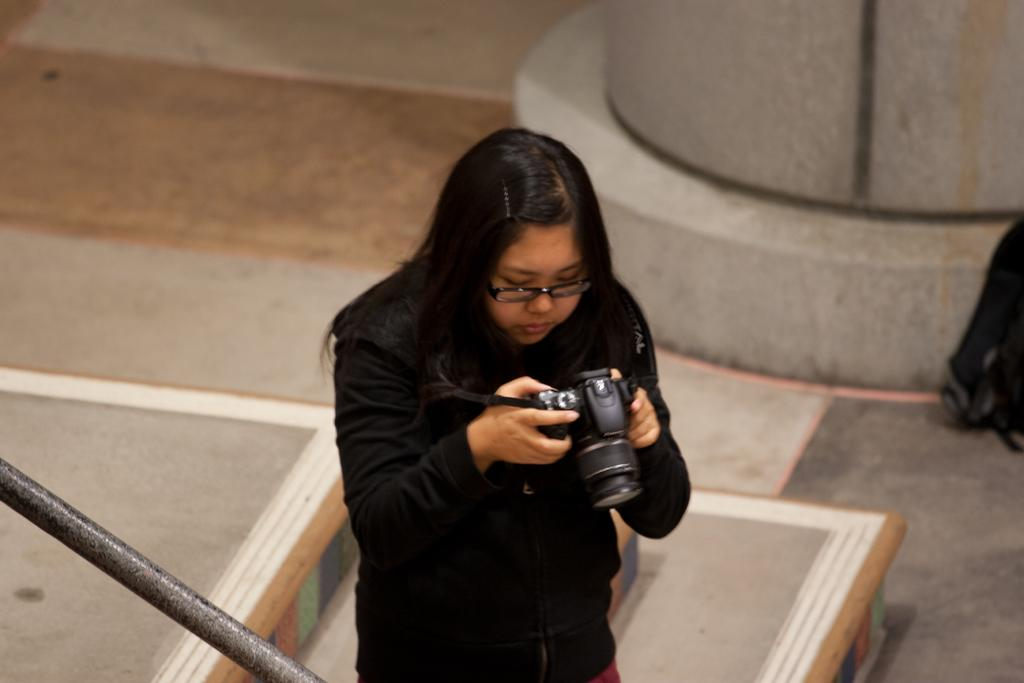What is the person in the image doing? The person is standing in the image and holding a camera. What can be seen near the person in the image? There is a pole in the image. What is on the ground in the image? There is a bag on the ground in the image. Can you describe any other objects in the image? There are some unspecified objects in the image. What type of berry can be seen growing on the pole in the image? There is no berry growing on the pole in the image; it is just shows a pole without any plants or fruits. 